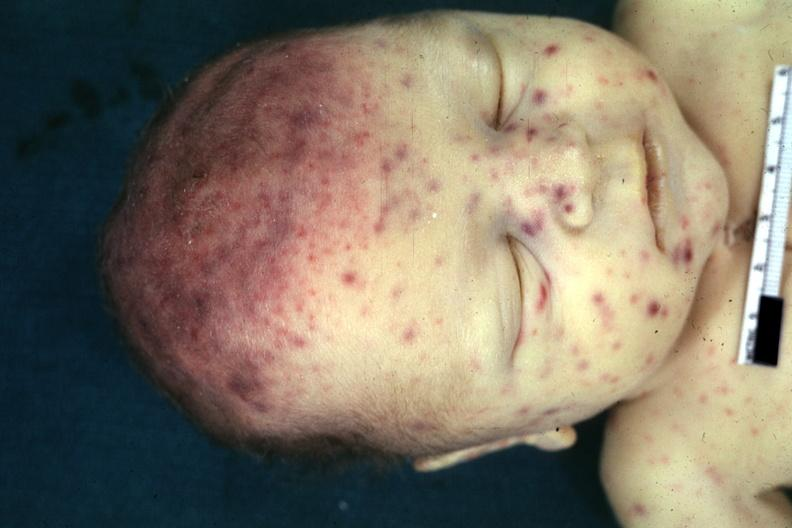where is this?
Answer the question using a single word or phrase. Skin 